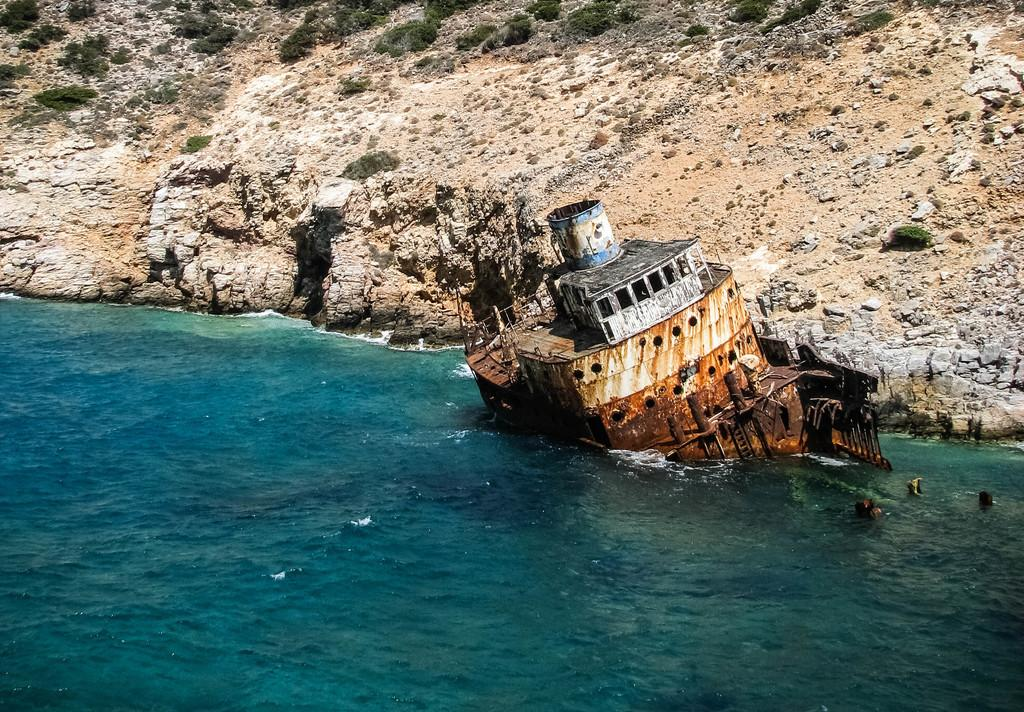What is the main subject of the image? There is a ship in the image. Where is the ship located? The ship is in the water. What other objects or features can be seen in the image? There are small plants and a rock visible in the image. What is the primary element present in the image? Water is visible in the image. Can you tell me how many bananas are hanging from the ship in the image? There are no bananas present in the image; it features a ship in the water with small plants and a rock. What type of frog can be seen jumping on the rock in the image? There is no frog present in the image; it only shows a ship, water, small plants, and a rock. 